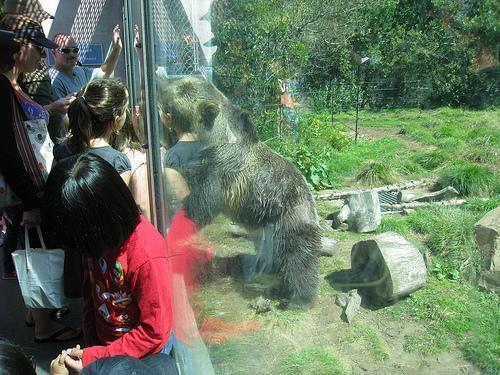How many people are wearing red shirt?
Give a very brief answer. 1. 